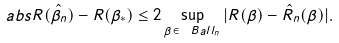Convert formula to latex. <formula><loc_0><loc_0><loc_500><loc_500>\ a b s { R ( \hat { \beta } _ { n } ) - R ( \beta _ { * } ) } \leq 2 \sup _ { \beta \in \ B a l l _ { n } } | R ( \beta ) - \hat { R } _ { n } ( \beta ) | .</formula> 